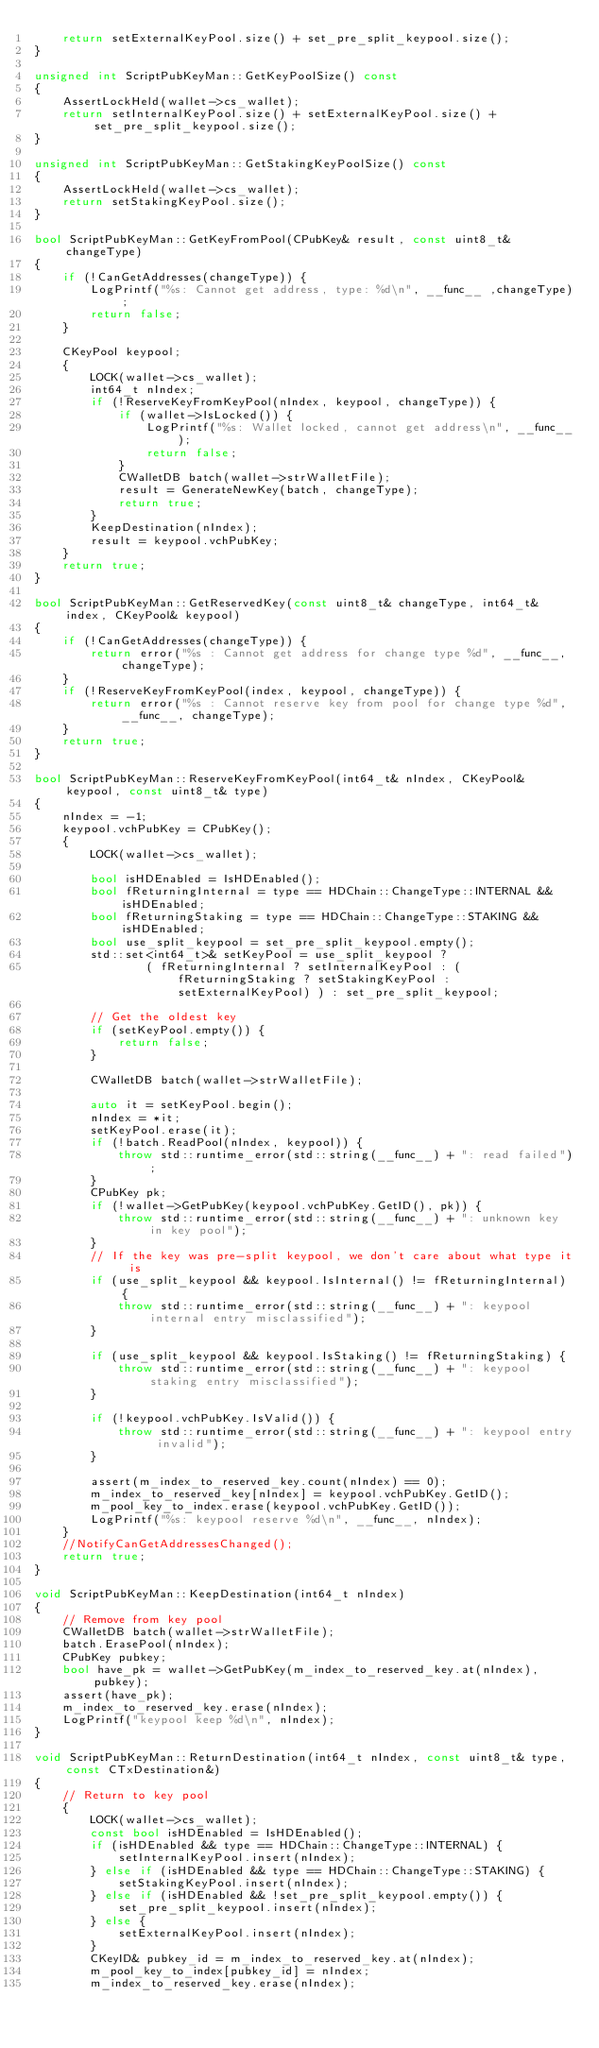<code> <loc_0><loc_0><loc_500><loc_500><_C++_>    return setExternalKeyPool.size() + set_pre_split_keypool.size();
}

unsigned int ScriptPubKeyMan::GetKeyPoolSize() const
{
    AssertLockHeld(wallet->cs_wallet);
    return setInternalKeyPool.size() + setExternalKeyPool.size() + set_pre_split_keypool.size();
}

unsigned int ScriptPubKeyMan::GetStakingKeyPoolSize() const
{
    AssertLockHeld(wallet->cs_wallet);
    return setStakingKeyPool.size();
}

bool ScriptPubKeyMan::GetKeyFromPool(CPubKey& result, const uint8_t& changeType)
{
    if (!CanGetAddresses(changeType)) {
        LogPrintf("%s: Cannot get address, type: %d\n", __func__ ,changeType);
        return false;
    }

    CKeyPool keypool;
    {
        LOCK(wallet->cs_wallet);
        int64_t nIndex;
        if (!ReserveKeyFromKeyPool(nIndex, keypool, changeType)) {
            if (wallet->IsLocked()) {
                LogPrintf("%s: Wallet locked, cannot get address\n", __func__);
                return false;
            }
            CWalletDB batch(wallet->strWalletFile);
            result = GenerateNewKey(batch, changeType);
            return true;
        }
        KeepDestination(nIndex);
        result = keypool.vchPubKey;
    }
    return true;
}

bool ScriptPubKeyMan::GetReservedKey(const uint8_t& changeType, int64_t& index, CKeyPool& keypool)
{
    if (!CanGetAddresses(changeType)) {
        return error("%s : Cannot get address for change type %d", __func__, changeType);
    }
    if (!ReserveKeyFromKeyPool(index, keypool, changeType)) {
        return error("%s : Cannot reserve key from pool for change type %d", __func__, changeType);
    }
    return true;
}

bool ScriptPubKeyMan::ReserveKeyFromKeyPool(int64_t& nIndex, CKeyPool& keypool, const uint8_t& type)
{
    nIndex = -1;
    keypool.vchPubKey = CPubKey();
    {
        LOCK(wallet->cs_wallet);

        bool isHDEnabled = IsHDEnabled();
        bool fReturningInternal = type == HDChain::ChangeType::INTERNAL && isHDEnabled;
        bool fReturningStaking = type == HDChain::ChangeType::STAKING && isHDEnabled;
        bool use_split_keypool = set_pre_split_keypool.empty();
        std::set<int64_t>& setKeyPool = use_split_keypool ?
                ( fReturningInternal ? setInternalKeyPool : (fReturningStaking ? setStakingKeyPool : setExternalKeyPool) ) : set_pre_split_keypool;

        // Get the oldest key
        if (setKeyPool.empty()) {
            return false;
        }

        CWalletDB batch(wallet->strWalletFile);

        auto it = setKeyPool.begin();
        nIndex = *it;
        setKeyPool.erase(it);
        if (!batch.ReadPool(nIndex, keypool)) {
            throw std::runtime_error(std::string(__func__) + ": read failed");
        }
        CPubKey pk;
        if (!wallet->GetPubKey(keypool.vchPubKey.GetID(), pk)) {
            throw std::runtime_error(std::string(__func__) + ": unknown key in key pool");
        }
        // If the key was pre-split keypool, we don't care about what type it is
        if (use_split_keypool && keypool.IsInternal() != fReturningInternal) {
            throw std::runtime_error(std::string(__func__) + ": keypool internal entry misclassified");
        }

        if (use_split_keypool && keypool.IsStaking() != fReturningStaking) {
            throw std::runtime_error(std::string(__func__) + ": keypool staking entry misclassified");
        }

        if (!keypool.vchPubKey.IsValid()) {
            throw std::runtime_error(std::string(__func__) + ": keypool entry invalid");
        }

        assert(m_index_to_reserved_key.count(nIndex) == 0);
        m_index_to_reserved_key[nIndex] = keypool.vchPubKey.GetID();
        m_pool_key_to_index.erase(keypool.vchPubKey.GetID());
        LogPrintf("%s: keypool reserve %d\n", __func__, nIndex);
    }
    //NotifyCanGetAddressesChanged();
    return true;
}

void ScriptPubKeyMan::KeepDestination(int64_t nIndex)
{
    // Remove from key pool
    CWalletDB batch(wallet->strWalletFile);
    batch.ErasePool(nIndex);
    CPubKey pubkey;
    bool have_pk = wallet->GetPubKey(m_index_to_reserved_key.at(nIndex), pubkey);
    assert(have_pk);
    m_index_to_reserved_key.erase(nIndex);
    LogPrintf("keypool keep %d\n", nIndex);
}

void ScriptPubKeyMan::ReturnDestination(int64_t nIndex, const uint8_t& type, const CTxDestination&)
{
    // Return to key pool
    {
        LOCK(wallet->cs_wallet);
        const bool isHDEnabled = IsHDEnabled();
        if (isHDEnabled && type == HDChain::ChangeType::INTERNAL) {
            setInternalKeyPool.insert(nIndex);
        } else if (isHDEnabled && type == HDChain::ChangeType::STAKING) {
            setStakingKeyPool.insert(nIndex);
        } else if (isHDEnabled && !set_pre_split_keypool.empty()) {
            set_pre_split_keypool.insert(nIndex);
        } else {
            setExternalKeyPool.insert(nIndex);
        }
        CKeyID& pubkey_id = m_index_to_reserved_key.at(nIndex);
        m_pool_key_to_index[pubkey_id] = nIndex;
        m_index_to_reserved_key.erase(nIndex);</code> 